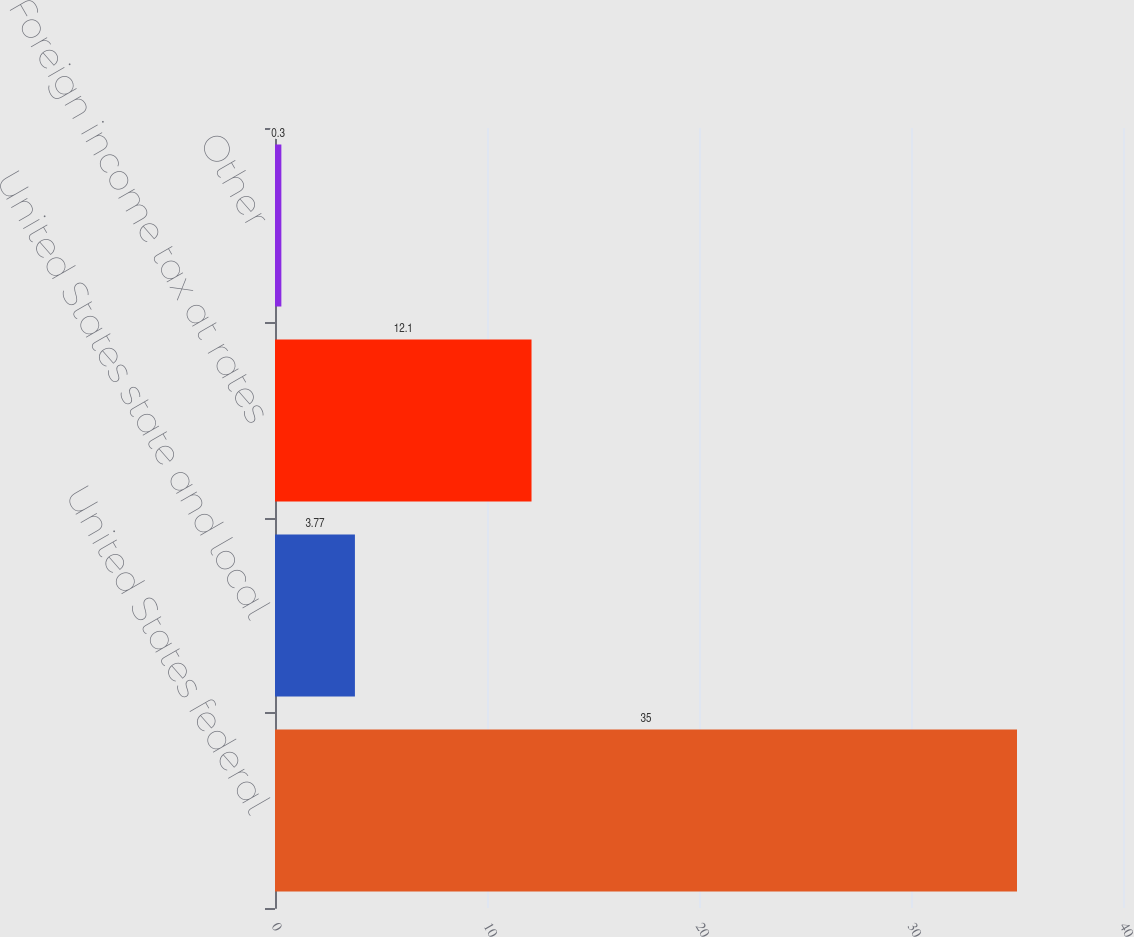Convert chart to OTSL. <chart><loc_0><loc_0><loc_500><loc_500><bar_chart><fcel>United States federal<fcel>United States state and local<fcel>Foreign income tax at rates<fcel>Other<nl><fcel>35<fcel>3.77<fcel>12.1<fcel>0.3<nl></chart> 